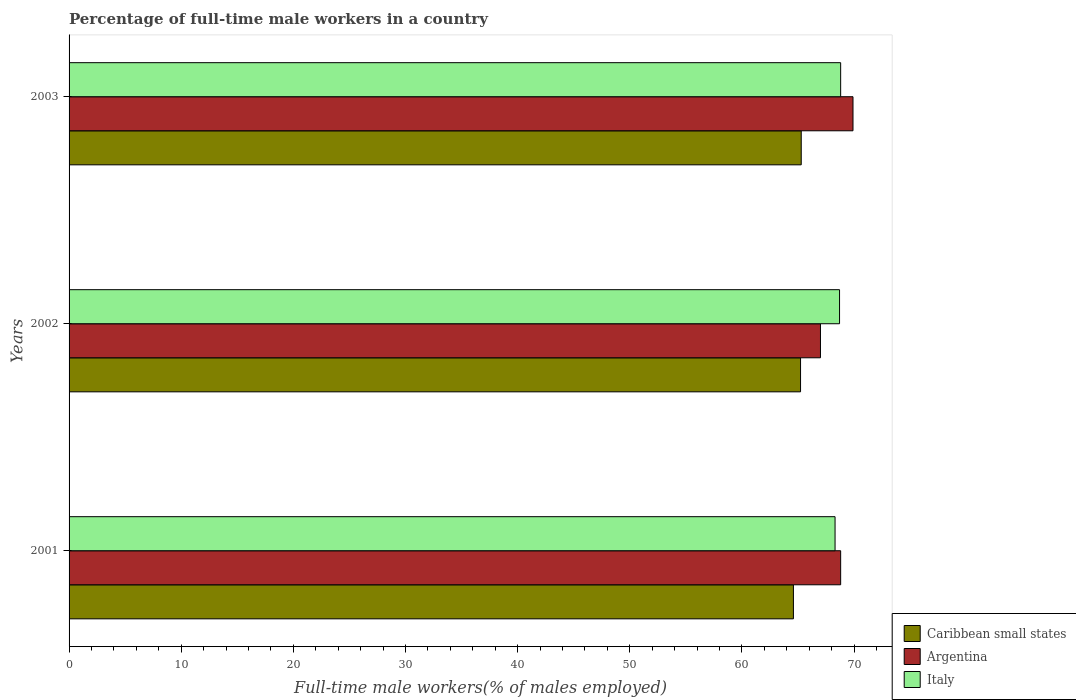How many groups of bars are there?
Provide a succinct answer. 3. Are the number of bars per tick equal to the number of legend labels?
Give a very brief answer. Yes. Are the number of bars on each tick of the Y-axis equal?
Your response must be concise. Yes. How many bars are there on the 1st tick from the top?
Your answer should be compact. 3. In how many cases, is the number of bars for a given year not equal to the number of legend labels?
Give a very brief answer. 0. What is the percentage of full-time male workers in Italy in 2003?
Give a very brief answer. 68.8. Across all years, what is the maximum percentage of full-time male workers in Caribbean small states?
Your answer should be very brief. 65.28. In which year was the percentage of full-time male workers in Italy maximum?
Offer a very short reply. 2003. In which year was the percentage of full-time male workers in Argentina minimum?
Offer a terse response. 2002. What is the total percentage of full-time male workers in Argentina in the graph?
Your answer should be compact. 205.7. What is the difference between the percentage of full-time male workers in Argentina in 2001 and that in 2002?
Ensure brevity in your answer.  1.8. What is the difference between the percentage of full-time male workers in Argentina in 2003 and the percentage of full-time male workers in Italy in 2002?
Your answer should be compact. 1.2. What is the average percentage of full-time male workers in Italy per year?
Ensure brevity in your answer.  68.6. In the year 2002, what is the difference between the percentage of full-time male workers in Italy and percentage of full-time male workers in Caribbean small states?
Your answer should be very brief. 3.48. In how many years, is the percentage of full-time male workers in Argentina greater than 50 %?
Your answer should be very brief. 3. What is the ratio of the percentage of full-time male workers in Italy in 2002 to that in 2003?
Offer a terse response. 1. Is the difference between the percentage of full-time male workers in Italy in 2001 and 2003 greater than the difference between the percentage of full-time male workers in Caribbean small states in 2001 and 2003?
Give a very brief answer. Yes. What is the difference between the highest and the second highest percentage of full-time male workers in Italy?
Your response must be concise. 0.1. What is the difference between the highest and the lowest percentage of full-time male workers in Argentina?
Offer a very short reply. 2.9. In how many years, is the percentage of full-time male workers in Italy greater than the average percentage of full-time male workers in Italy taken over all years?
Your answer should be very brief. 2. What does the 2nd bar from the top in 2003 represents?
Give a very brief answer. Argentina. What does the 1st bar from the bottom in 2003 represents?
Ensure brevity in your answer.  Caribbean small states. Are all the bars in the graph horizontal?
Your response must be concise. Yes. How many years are there in the graph?
Your response must be concise. 3. What is the difference between two consecutive major ticks on the X-axis?
Keep it short and to the point. 10. Are the values on the major ticks of X-axis written in scientific E-notation?
Give a very brief answer. No. Does the graph contain grids?
Ensure brevity in your answer.  No. Where does the legend appear in the graph?
Your answer should be very brief. Bottom right. How many legend labels are there?
Make the answer very short. 3. How are the legend labels stacked?
Your answer should be compact. Vertical. What is the title of the graph?
Your response must be concise. Percentage of full-time male workers in a country. Does "Northern Mariana Islands" appear as one of the legend labels in the graph?
Your answer should be very brief. No. What is the label or title of the X-axis?
Give a very brief answer. Full-time male workers(% of males employed). What is the Full-time male workers(% of males employed) in Caribbean small states in 2001?
Offer a very short reply. 64.59. What is the Full-time male workers(% of males employed) of Argentina in 2001?
Your answer should be very brief. 68.8. What is the Full-time male workers(% of males employed) in Italy in 2001?
Provide a short and direct response. 68.3. What is the Full-time male workers(% of males employed) of Caribbean small states in 2002?
Your answer should be compact. 65.22. What is the Full-time male workers(% of males employed) in Argentina in 2002?
Keep it short and to the point. 67. What is the Full-time male workers(% of males employed) in Italy in 2002?
Keep it short and to the point. 68.7. What is the Full-time male workers(% of males employed) in Caribbean small states in 2003?
Provide a succinct answer. 65.28. What is the Full-time male workers(% of males employed) of Argentina in 2003?
Keep it short and to the point. 69.9. What is the Full-time male workers(% of males employed) of Italy in 2003?
Ensure brevity in your answer.  68.8. Across all years, what is the maximum Full-time male workers(% of males employed) of Caribbean small states?
Keep it short and to the point. 65.28. Across all years, what is the maximum Full-time male workers(% of males employed) in Argentina?
Provide a succinct answer. 69.9. Across all years, what is the maximum Full-time male workers(% of males employed) of Italy?
Offer a very short reply. 68.8. Across all years, what is the minimum Full-time male workers(% of males employed) in Caribbean small states?
Provide a succinct answer. 64.59. Across all years, what is the minimum Full-time male workers(% of males employed) in Argentina?
Provide a short and direct response. 67. Across all years, what is the minimum Full-time male workers(% of males employed) of Italy?
Ensure brevity in your answer.  68.3. What is the total Full-time male workers(% of males employed) of Caribbean small states in the graph?
Give a very brief answer. 195.09. What is the total Full-time male workers(% of males employed) of Argentina in the graph?
Provide a succinct answer. 205.7. What is the total Full-time male workers(% of males employed) of Italy in the graph?
Your response must be concise. 205.8. What is the difference between the Full-time male workers(% of males employed) of Caribbean small states in 2001 and that in 2002?
Your answer should be compact. -0.63. What is the difference between the Full-time male workers(% of males employed) of Argentina in 2001 and that in 2002?
Offer a terse response. 1.8. What is the difference between the Full-time male workers(% of males employed) in Italy in 2001 and that in 2002?
Provide a short and direct response. -0.4. What is the difference between the Full-time male workers(% of males employed) in Caribbean small states in 2001 and that in 2003?
Give a very brief answer. -0.7. What is the difference between the Full-time male workers(% of males employed) of Italy in 2001 and that in 2003?
Make the answer very short. -0.5. What is the difference between the Full-time male workers(% of males employed) of Caribbean small states in 2002 and that in 2003?
Your response must be concise. -0.06. What is the difference between the Full-time male workers(% of males employed) of Caribbean small states in 2001 and the Full-time male workers(% of males employed) of Argentina in 2002?
Offer a terse response. -2.41. What is the difference between the Full-time male workers(% of males employed) of Caribbean small states in 2001 and the Full-time male workers(% of males employed) of Italy in 2002?
Your answer should be very brief. -4.11. What is the difference between the Full-time male workers(% of males employed) of Caribbean small states in 2001 and the Full-time male workers(% of males employed) of Argentina in 2003?
Your response must be concise. -5.31. What is the difference between the Full-time male workers(% of males employed) of Caribbean small states in 2001 and the Full-time male workers(% of males employed) of Italy in 2003?
Ensure brevity in your answer.  -4.21. What is the difference between the Full-time male workers(% of males employed) of Argentina in 2001 and the Full-time male workers(% of males employed) of Italy in 2003?
Offer a very short reply. 0. What is the difference between the Full-time male workers(% of males employed) of Caribbean small states in 2002 and the Full-time male workers(% of males employed) of Argentina in 2003?
Provide a short and direct response. -4.68. What is the difference between the Full-time male workers(% of males employed) of Caribbean small states in 2002 and the Full-time male workers(% of males employed) of Italy in 2003?
Your response must be concise. -3.58. What is the difference between the Full-time male workers(% of males employed) in Argentina in 2002 and the Full-time male workers(% of males employed) in Italy in 2003?
Make the answer very short. -1.8. What is the average Full-time male workers(% of males employed) in Caribbean small states per year?
Your answer should be very brief. 65.03. What is the average Full-time male workers(% of males employed) of Argentina per year?
Provide a short and direct response. 68.57. What is the average Full-time male workers(% of males employed) of Italy per year?
Offer a terse response. 68.6. In the year 2001, what is the difference between the Full-time male workers(% of males employed) of Caribbean small states and Full-time male workers(% of males employed) of Argentina?
Provide a succinct answer. -4.21. In the year 2001, what is the difference between the Full-time male workers(% of males employed) of Caribbean small states and Full-time male workers(% of males employed) of Italy?
Provide a short and direct response. -3.71. In the year 2001, what is the difference between the Full-time male workers(% of males employed) in Argentina and Full-time male workers(% of males employed) in Italy?
Ensure brevity in your answer.  0.5. In the year 2002, what is the difference between the Full-time male workers(% of males employed) in Caribbean small states and Full-time male workers(% of males employed) in Argentina?
Ensure brevity in your answer.  -1.78. In the year 2002, what is the difference between the Full-time male workers(% of males employed) in Caribbean small states and Full-time male workers(% of males employed) in Italy?
Provide a short and direct response. -3.48. In the year 2003, what is the difference between the Full-time male workers(% of males employed) in Caribbean small states and Full-time male workers(% of males employed) in Argentina?
Provide a short and direct response. -4.62. In the year 2003, what is the difference between the Full-time male workers(% of males employed) of Caribbean small states and Full-time male workers(% of males employed) of Italy?
Your answer should be very brief. -3.52. What is the ratio of the Full-time male workers(% of males employed) of Caribbean small states in 2001 to that in 2002?
Your answer should be compact. 0.99. What is the ratio of the Full-time male workers(% of males employed) in Argentina in 2001 to that in 2002?
Provide a short and direct response. 1.03. What is the ratio of the Full-time male workers(% of males employed) in Italy in 2001 to that in 2002?
Provide a short and direct response. 0.99. What is the ratio of the Full-time male workers(% of males employed) in Caribbean small states in 2001 to that in 2003?
Make the answer very short. 0.99. What is the ratio of the Full-time male workers(% of males employed) of Argentina in 2001 to that in 2003?
Offer a terse response. 0.98. What is the ratio of the Full-time male workers(% of males employed) of Argentina in 2002 to that in 2003?
Your answer should be very brief. 0.96. What is the difference between the highest and the second highest Full-time male workers(% of males employed) of Caribbean small states?
Offer a terse response. 0.06. What is the difference between the highest and the second highest Full-time male workers(% of males employed) in Argentina?
Provide a succinct answer. 1.1. What is the difference between the highest and the lowest Full-time male workers(% of males employed) of Caribbean small states?
Give a very brief answer. 0.7. What is the difference between the highest and the lowest Full-time male workers(% of males employed) in Argentina?
Your answer should be very brief. 2.9. 